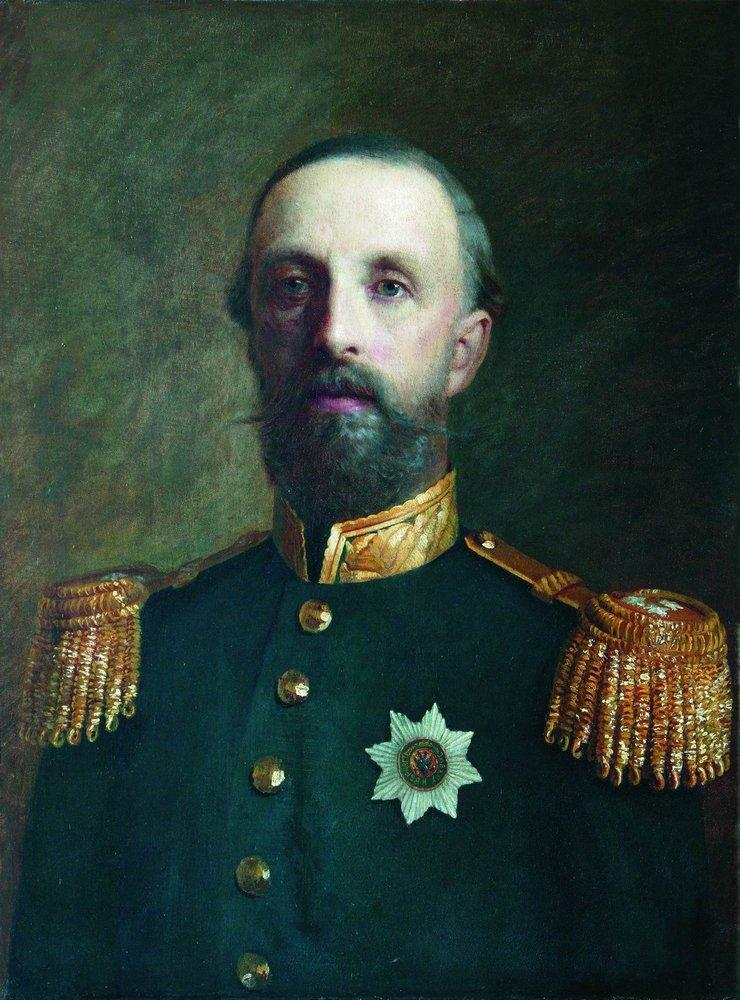What is this photo about'?
 The image portrays a man in a military uniform, captured in the genre of portraiture. The man is distinguished by his long beard and mustache. His attire is a dark blue jacket adorned with gold epaulettes, and a white star graces his chest, signifying his rank or achievements. The background is a somber dark brown, providing a stark contrast to the figure in the foreground. The art style leans towards realism, capturing the intricate details of the man's features and uniform with precision. The overall composition of the image suggests a sense of authority and respect associated with the man's military position. 